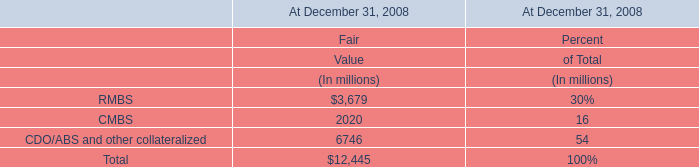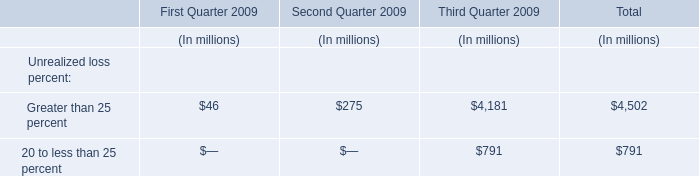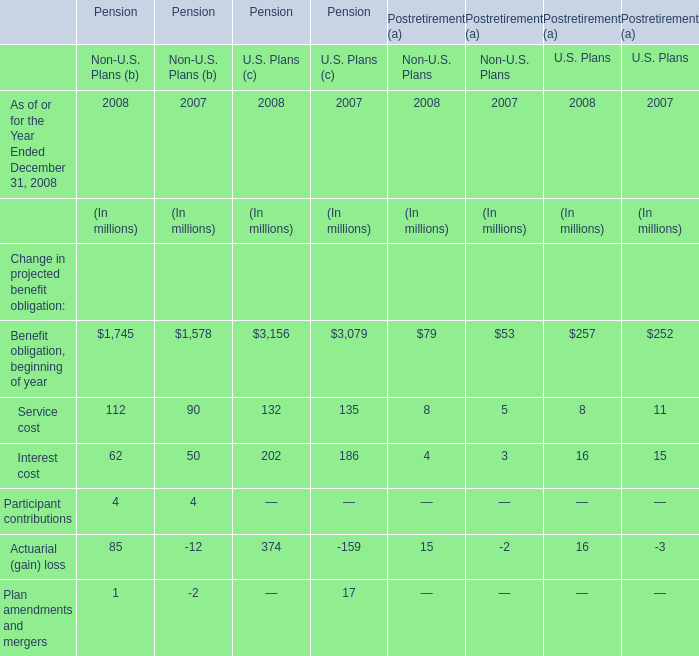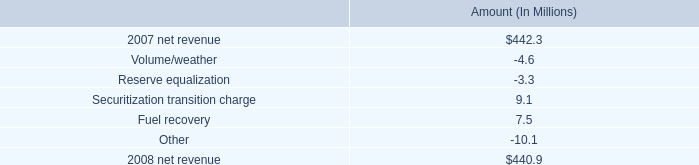How many Service cost exceed the average of Service cost in 2008? 
Answer: 1. 